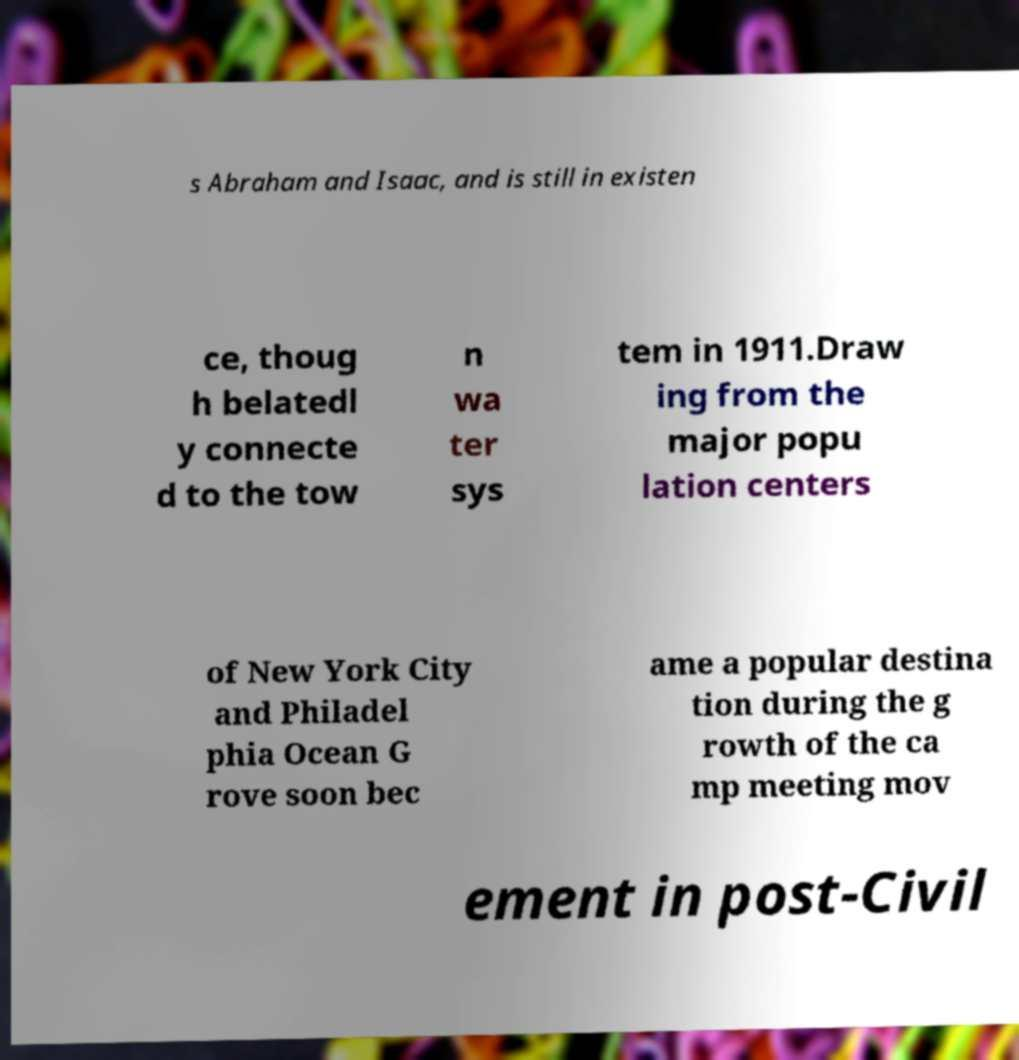Can you read and provide the text displayed in the image?This photo seems to have some interesting text. Can you extract and type it out for me? s Abraham and Isaac, and is still in existen ce, thoug h belatedl y connecte d to the tow n wa ter sys tem in 1911.Draw ing from the major popu lation centers of New York City and Philadel phia Ocean G rove soon bec ame a popular destina tion during the g rowth of the ca mp meeting mov ement in post-Civil 